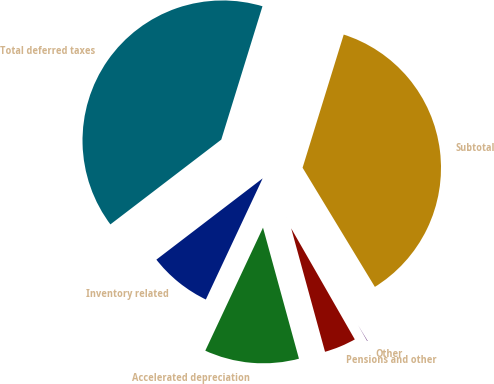Convert chart to OTSL. <chart><loc_0><loc_0><loc_500><loc_500><pie_chart><fcel>Inventory related<fcel>Accelerated depreciation<fcel>Pensions and other<fcel>Other<fcel>Subtotal<fcel>Total deferred taxes<nl><fcel>7.63%<fcel>11.24%<fcel>4.02%<fcel>0.4%<fcel>36.55%<fcel>40.16%<nl></chart> 